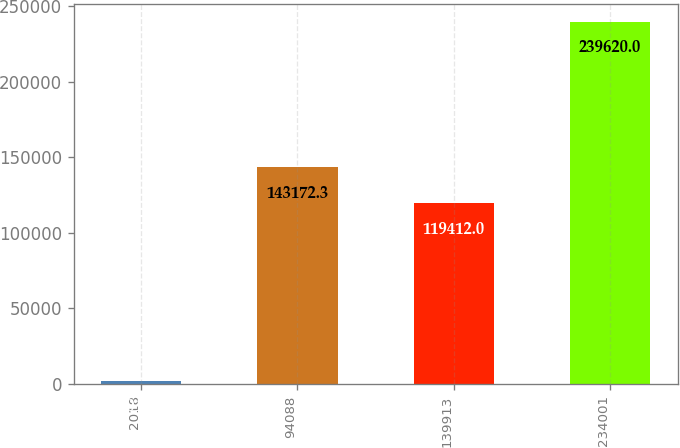Convert chart to OTSL. <chart><loc_0><loc_0><loc_500><loc_500><bar_chart><fcel>2018<fcel>94088<fcel>139913<fcel>234001<nl><fcel>2017<fcel>143172<fcel>119412<fcel>239620<nl></chart> 